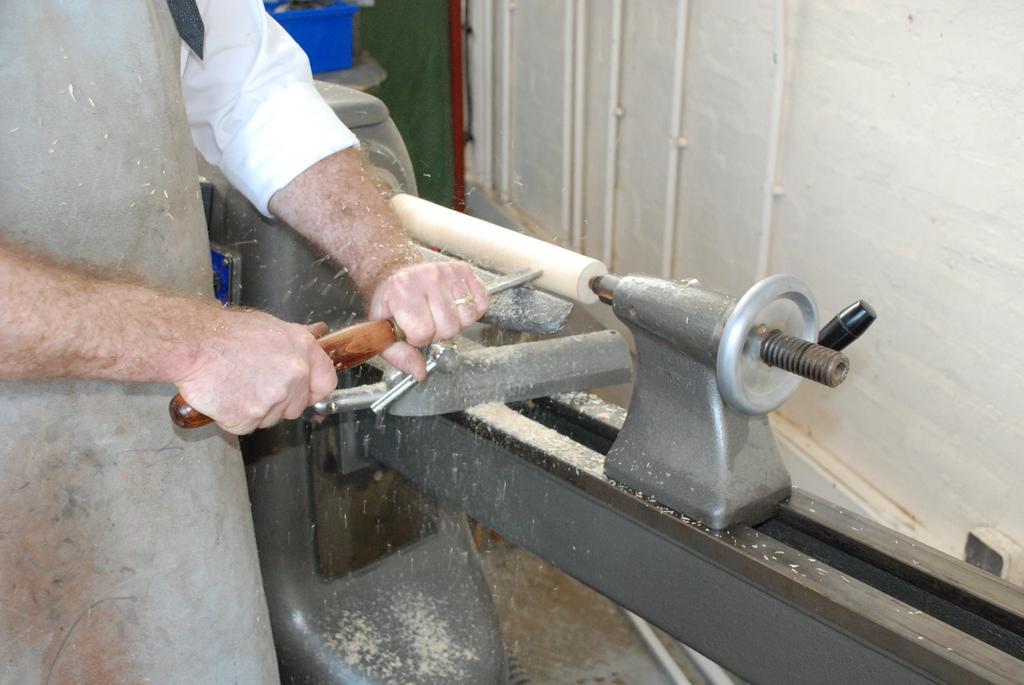Describe this image in one or two sentences. In this image we can see a person holding an object, there is a mechanical instrument, also we can see the wall. 